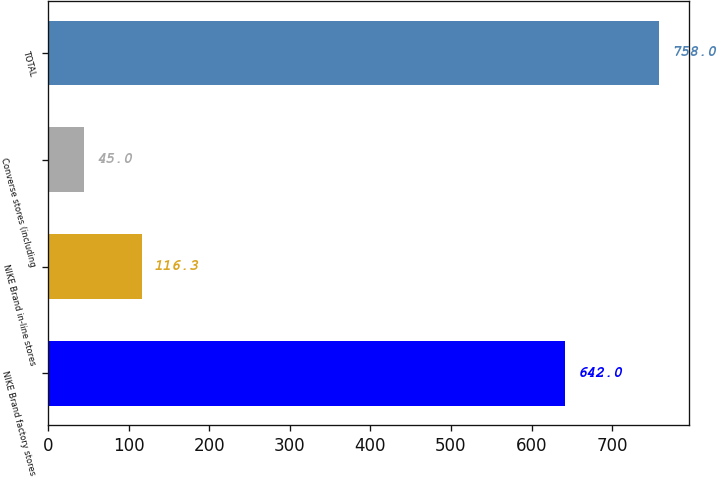Convert chart. <chart><loc_0><loc_0><loc_500><loc_500><bar_chart><fcel>NIKE Brand factory stores<fcel>NIKE Brand in-line stores<fcel>Converse stores (including<fcel>TOTAL<nl><fcel>642<fcel>116.3<fcel>45<fcel>758<nl></chart> 